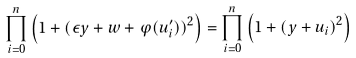Convert formula to latex. <formula><loc_0><loc_0><loc_500><loc_500>\prod _ { i = 0 } ^ { n } \left ( 1 + ( \epsilon y + w + \varphi ( u ^ { \prime } _ { i } ) ) ^ { 2 } \right ) = \prod _ { i = 0 } ^ { n } \left ( 1 + ( y + u _ { i } ) ^ { 2 } \right )</formula> 